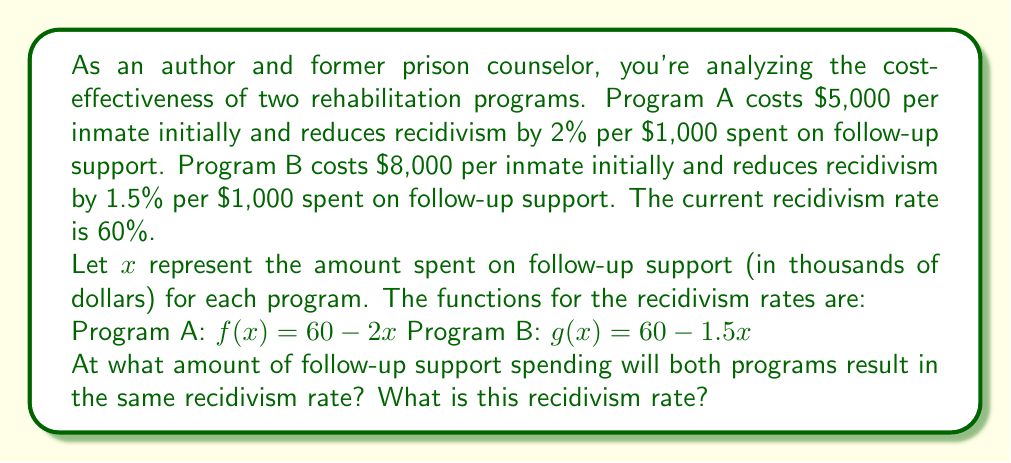Solve this math problem. To solve this problem, we need to find the point where the two functions intersect. This occurs when $f(x) = g(x)$.

1) Set up the equation:
   $60 - 2x = 60 - 1.5x$

2) Subtract 60 from both sides:
   $-2x = -1.5x$

3) Subtract $-1.5x$ from both sides:
   $-0.5x = 0$

4) Divide both sides by $-0.5$:
   $x = 0$

This means the functions intersect when $x = 0$, which represents no follow-up support spending.

5) To find the recidivism rate at this point, we can use either function. Let's use $f(x)$:
   $f(0) = 60 - 2(0) = 60$

6) To calculate the total cost for each program at this point:
   Program A: $5,000 + (0 * 1,000) = $5,000
   Program B: $8,000 + (0 * 1,000) = $8,000

Therefore, without any follow-up support spending, both programs result in the same recidivism rate of 60%, which is the same as the initial rate. Program A is more cost-effective as it achieves the same result at a lower cost.
Answer: Both programs result in the same recidivism rate of 60% when $0 is spent on follow-up support. At this point, Program A costs $5,000 per inmate and Program B costs $8,000 per inmate. 